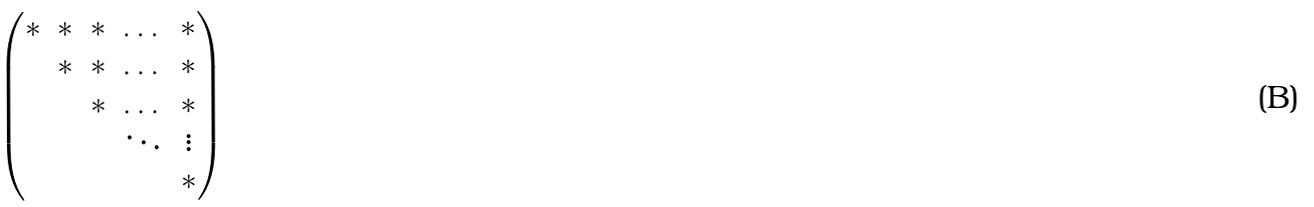<formula> <loc_0><loc_0><loc_500><loc_500>\begin{pmatrix} \ast & \ast & \ast & \dots & \ast \\ & \ast & \ast & \dots & \ast \\ & & \ast & \dots & \ast \\ & & & \ddots & \vdots \\ & & & & \ast \end{pmatrix}</formula> 